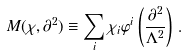<formula> <loc_0><loc_0><loc_500><loc_500>M ( \chi , \partial ^ { 2 } ) \equiv \sum _ { i } \chi _ { i } \varphi ^ { i } \left ( \frac { \partial ^ { 2 } } { \Lambda ^ { 2 } } \right ) \, .</formula> 